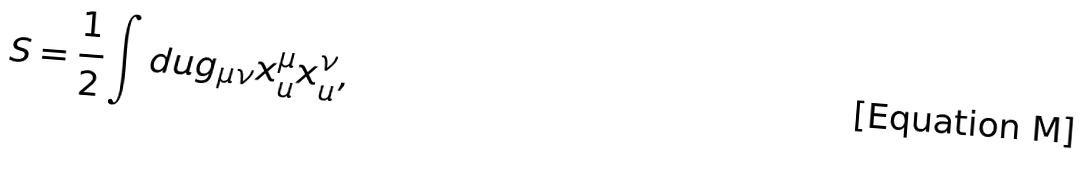<formula> <loc_0><loc_0><loc_500><loc_500>S = \frac { 1 } { 2 } \int d u g _ { \mu \nu } x ^ { \mu } _ { u } x ^ { \nu } _ { u } , \quad</formula> 